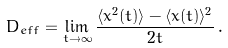Convert formula to latex. <formula><loc_0><loc_0><loc_500><loc_500>D _ { e f f } = \lim _ { t \to \infty } \frac { \langle x ^ { 2 } ( t ) \rangle - \langle x ( t ) \rangle ^ { 2 } } { 2 t } \, .</formula> 